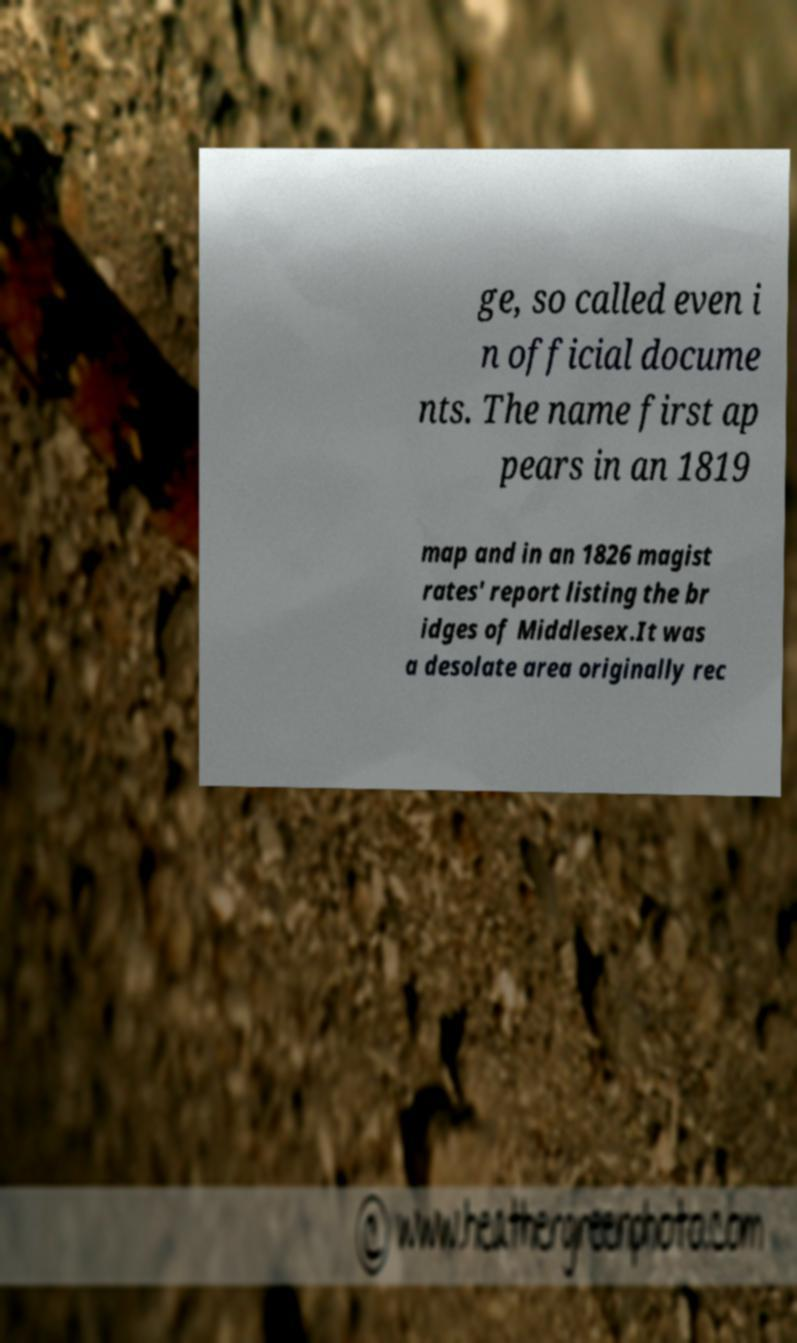Please identify and transcribe the text found in this image. ge, so called even i n official docume nts. The name first ap pears in an 1819 map and in an 1826 magist rates' report listing the br idges of Middlesex.It was a desolate area originally rec 